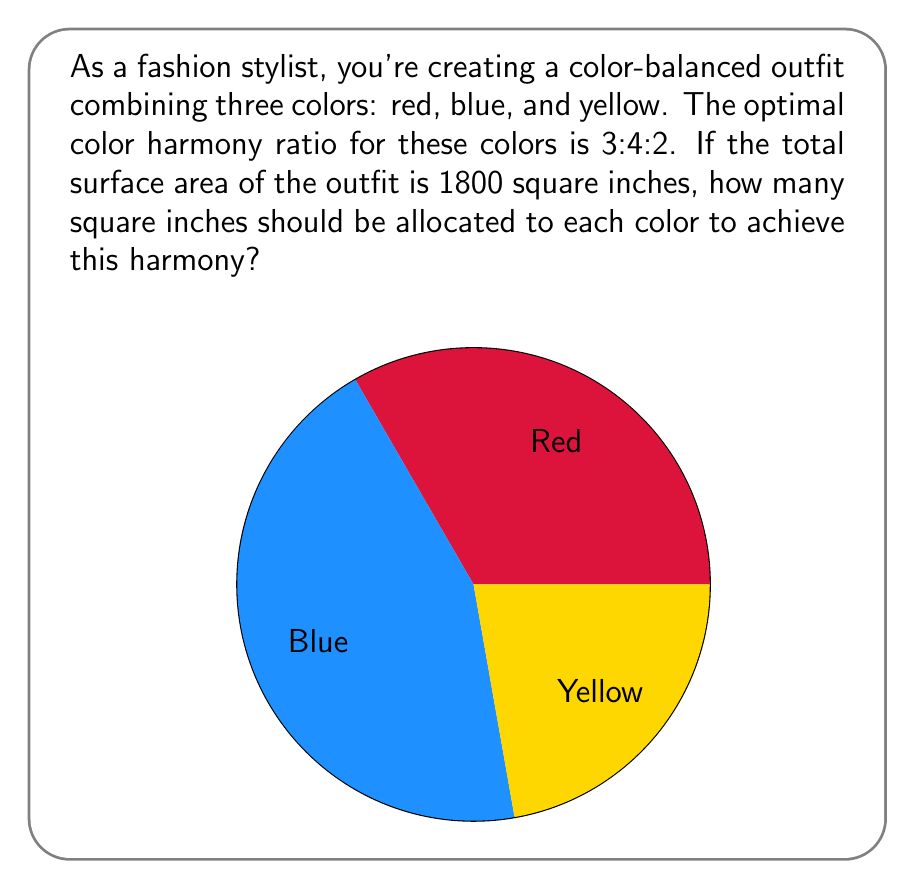Teach me how to tackle this problem. Let's approach this step-by-step:

1) The given ratio is 3:4:2 for red:blue:yellow.

2) To find the total parts in the ratio, we sum these numbers:
   $3 + 4 + 2 = 9$ total parts

3) Now, let's calculate the value of each part:
   Total area ÷ Total parts = Value per part
   $1800 \div 9 = 200$ square inches per part

4) Now we can calculate the area for each color:

   Red: $3 \times 200 = 600$ square inches
   Blue: $4 \times 200 = 800$ square inches
   Yellow: $2 \times 200 = 400$ square inches

5) Let's verify:
   $600 + 800 + 400 = 1800$ square inches (total area)

Therefore, to achieve the optimal color harmony ratio, the outfit should consist of 600 square inches of red, 800 square inches of blue, and 400 square inches of yellow.
Answer: Red: 600 sq in, Blue: 800 sq in, Yellow: 400 sq in 